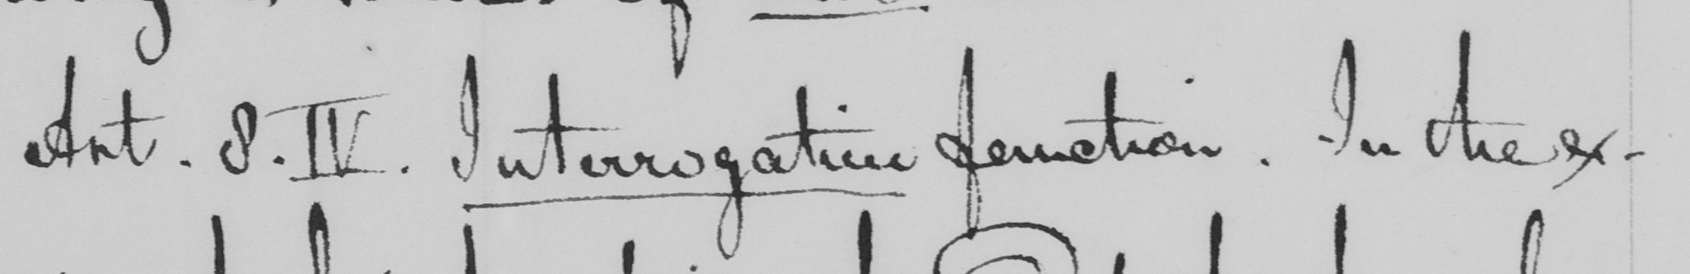Please transcribe the handwritten text in this image. Ant .8.IV . Interrogative function . In the ex- 